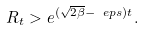Convert formula to latex. <formula><loc_0><loc_0><loc_500><loc_500>R _ { t } > e ^ { ( \sqrt { 2 \beta } - \ e p s ) t } .</formula> 